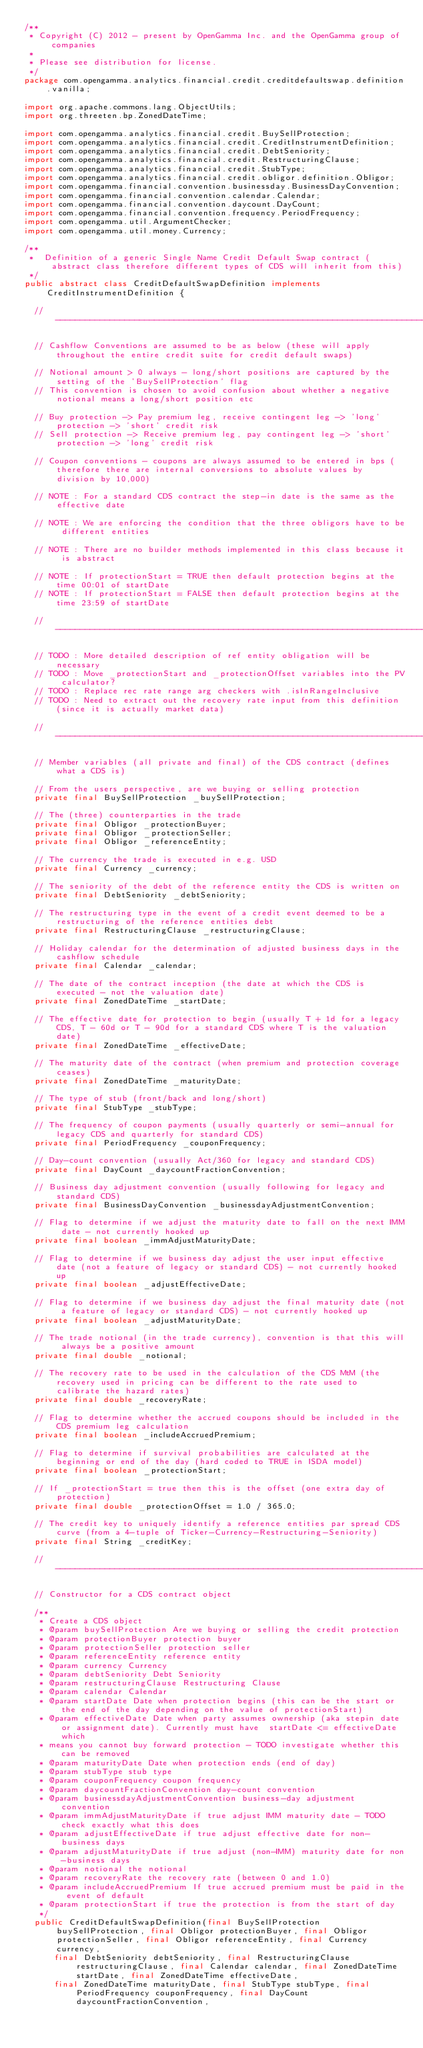Convert code to text. <code><loc_0><loc_0><loc_500><loc_500><_Java_>/**
 * Copyright (C) 2012 - present by OpenGamma Inc. and the OpenGamma group of companies
 * 
 * Please see distribution for license.
 */
package com.opengamma.analytics.financial.credit.creditdefaultswap.definition.vanilla;

import org.apache.commons.lang.ObjectUtils;
import org.threeten.bp.ZonedDateTime;

import com.opengamma.analytics.financial.credit.BuySellProtection;
import com.opengamma.analytics.financial.credit.CreditInstrumentDefinition;
import com.opengamma.analytics.financial.credit.DebtSeniority;
import com.opengamma.analytics.financial.credit.RestructuringClause;
import com.opengamma.analytics.financial.credit.StubType;
import com.opengamma.analytics.financial.credit.obligor.definition.Obligor;
import com.opengamma.financial.convention.businessday.BusinessDayConvention;
import com.opengamma.financial.convention.calendar.Calendar;
import com.opengamma.financial.convention.daycount.DayCount;
import com.opengamma.financial.convention.frequency.PeriodFrequency;
import com.opengamma.util.ArgumentChecker;
import com.opengamma.util.money.Currency;

/**
 *  Definition of a generic Single Name Credit Default Swap contract (abstract class therefore different types of CDS will inherit from this)
 */
public abstract class CreditDefaultSwapDefinition implements CreditInstrumentDefinition {

  // ----------------------------------------------------------------------------------------------------------------------------------------

  // Cashflow Conventions are assumed to be as below (these will apply throughout the entire credit suite for credit default swaps)

  // Notional amount > 0 always - long/short positions are captured by the setting of the 'BuySellProtection' flag
  // This convention is chosen to avoid confusion about whether a negative notional means a long/short position etc

  // Buy protection -> Pay premium leg, receive contingent leg -> 'long' protection -> 'short' credit risk
  // Sell protection -> Receive premium leg, pay contingent leg -> 'short' protection -> 'long' credit risk

  // Coupon conventions - coupons are always assumed to be entered in bps (therefore there are internal conversions to absolute values by division by 10,000)

  // NOTE : For a standard CDS contract the step-in date is the same as the effective date

  // NOTE : We are enforcing the condition that the three obligors have to be different entities

  // NOTE : There are no builder methods implemented in this class because it is abstract

  // NOTE : If protectionStart = TRUE then default protection begins at the time 00:01 of startDate
  // NOTE : If protectionStart = FALSE then default protection begins at the time 23:59 of startDate

  // ----------------------------------------------------------------------------------------------------------------------------------------

  // TODO : More detailed description of ref entity obligation will be necessary
  // TODO : Move _protectionStart and _protectionOffset variables into the PV calculator?
  // TODO : Replace rec rate range arg checkers with .isInRangeInclusive
  // TODO : Need to extract out the recovery rate input from this definition (since it is actually market data)

  // ----------------------------------------------------------------------------------------------------------------------------------------

  // Member variables (all private and final) of the CDS contract (defines what a CDS is)

  // From the users perspective, are we buying or selling protection
  private final BuySellProtection _buySellProtection;

  // The (three) counterparties in the trade
  private final Obligor _protectionBuyer;
  private final Obligor _protectionSeller;
  private final Obligor _referenceEntity;

  // The currency the trade is executed in e.g. USD
  private final Currency _currency;

  // The seniority of the debt of the reference entity the CDS is written on
  private final DebtSeniority _debtSeniority;

  // The restructuring type in the event of a credit event deemed to be a restructuring of the reference entities debt
  private final RestructuringClause _restructuringClause;

  // Holiday calendar for the determination of adjusted business days in the cashflow schedule
  private final Calendar _calendar;

  // The date of the contract inception (the date at which the CDS is executed - not the valuation date)
  private final ZonedDateTime _startDate;

  // The effective date for protection to begin (usually T + 1d for a legacy CDS, T - 60d or T - 90d for a standard CDS where T is the valuation date)
  private final ZonedDateTime _effectiveDate;

  // The maturity date of the contract (when premium and protection coverage ceases)
  private final ZonedDateTime _maturityDate;

  // The type of stub (front/back and long/short)
  private final StubType _stubType;

  // The frequency of coupon payments (usually quarterly or semi-annual for legacy CDS and quarterly for standard CDS)
  private final PeriodFrequency _couponFrequency;

  // Day-count convention (usually Act/360 for legacy and standard CDS)
  private final DayCount _daycountFractionConvention;

  // Business day adjustment convention (usually following for legacy and standard CDS)
  private final BusinessDayConvention _businessdayAdjustmentConvention;

  // Flag to determine if we adjust the maturity date to fall on the next IMM date - not currently hooked up
  private final boolean _immAdjustMaturityDate;

  // Flag to determine if we business day adjust the user input effective date (not a feature of legacy or standard CDS) - not currently hooked up
  private final boolean _adjustEffectiveDate;

  // Flag to determine if we business day adjust the final maturity date (not a feature of legacy or standard CDS) - not currently hooked up
  private final boolean _adjustMaturityDate;

  // The trade notional (in the trade currency), convention is that this will always be a positive amount
  private final double _notional;

  // The recovery rate to be used in the calculation of the CDS MtM (the recovery used in pricing can be different to the rate used to calibrate the hazard rates)
  private final double _recoveryRate;

  // Flag to determine whether the accrued coupons should be included in the CDS premium leg calculation
  private final boolean _includeAccruedPremium;

  // Flag to determine if survival probabilities are calculated at the beginning or end of the day (hard coded to TRUE in ISDA model)
  private final boolean _protectionStart;

  // If _protectionStart = true then this is the offset (one extra day of protection)
  private final double _protectionOffset = 1.0 / 365.0;

  // The credit key to uniquely identify a reference entities par spread CDS curve (from a 4-tuple of Ticker-Currency-Restructuring-Seniority)
  private final String _creditKey;

  // ----------------------------------------------------------------------------------------------------------------------------------------

  // Constructor for a CDS contract object

  /**
   * Create a CDS object 
   * @param buySellProtection Are we buying or selling the credit protection
   * @param protectionBuyer protection buyer
   * @param protectionSeller protection seller
   * @param referenceEntity reference entity
   * @param currency Currency 
   * @param debtSeniority Debt Seniority
   * @param restructuringClause Restructuring Clause
   * @param calendar Calendar
   * @param startDate Date when protection begins (this can be the start or the end of the day depending on the value of protectionStart)
   * @param effectiveDate Date when party assumes ownership (aka stepin date or assignment date). Currently must have  startDate <= effectiveDate which
   * means you cannot buy forward protection - TODO investigate whether this can be removed
   * @param maturityDate Date when protection ends (end of day)
   * @param stubType stub type
   * @param couponFrequency coupon frequency
   * @param daycountFractionConvention day-count convention
   * @param businessdayAdjustmentConvention business-day adjustment convention
   * @param immAdjustMaturityDate if true adjust IMM maturity date - TODO check exactly what this does 
   * @param adjustEffectiveDate if true adjust effective date for non-business days 
   * @param adjustMaturityDate if true adjust (non-IMM) maturity date for non-business days 
   * @param notional the notional 
   * @param recoveryRate the recovery rate (between 0 and 1.0)
   * @param includeAccruedPremium If true accrued premium must be paid in the event of default
   * @param protectionStart if true the protection is from the start of day 
   */
  public CreditDefaultSwapDefinition(final BuySellProtection buySellProtection, final Obligor protectionBuyer, final Obligor protectionSeller, final Obligor referenceEntity, final Currency currency,
      final DebtSeniority debtSeniority, final RestructuringClause restructuringClause, final Calendar calendar, final ZonedDateTime startDate, final ZonedDateTime effectiveDate,
      final ZonedDateTime maturityDate, final StubType stubType, final PeriodFrequency couponFrequency, final DayCount daycountFractionConvention,</code> 